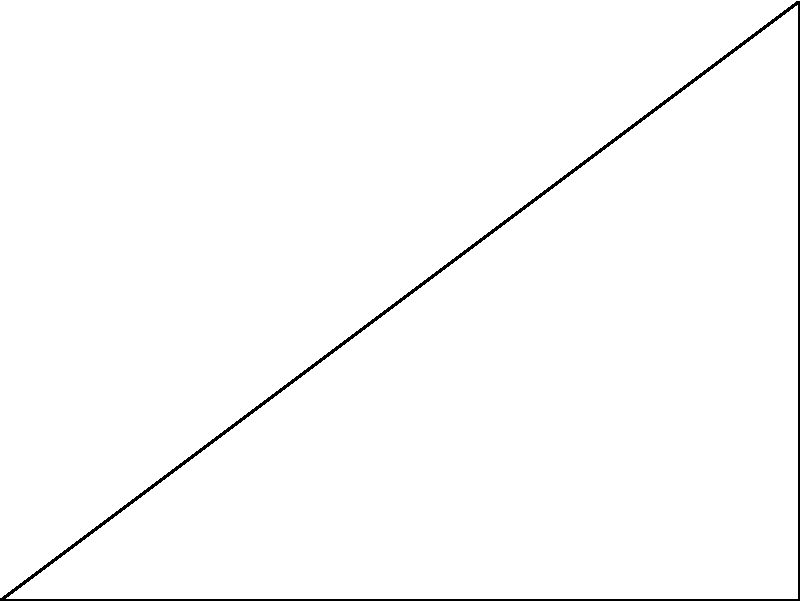In the given figure, angle ABC is a right angle. If the measure of angle BAC is 60°, what is the measure of angle BCA? Express your answer in degrees. Let's approach this step-by-step:

1) First, recall that the sum of angles in a triangle is always 180°.

2) We're given that angle ABC is a right angle, which means it measures 90°.

3) We're also told that angle BAC measures 60°.

4) Let's call the measure of angle BCA $x°$.

5) Now we can set up an equation based on the fact that the angles in a triangle sum to 180°:

   $90° + 60° + x° = 180°$

6) Simplify:
   $150° + x° = 180°$

7) Subtract 150° from both sides:
   $x° = 30°$

8) Therefore, the measure of angle BCA is 30°.

This problem demonstrates the application of complementary angles (two angles that sum to 90°) and supplementary angles (two angles that sum to 180°) in the context of triangle geometry, concepts that are fundamental in abstract algebra and group theory.
Answer: 30° 